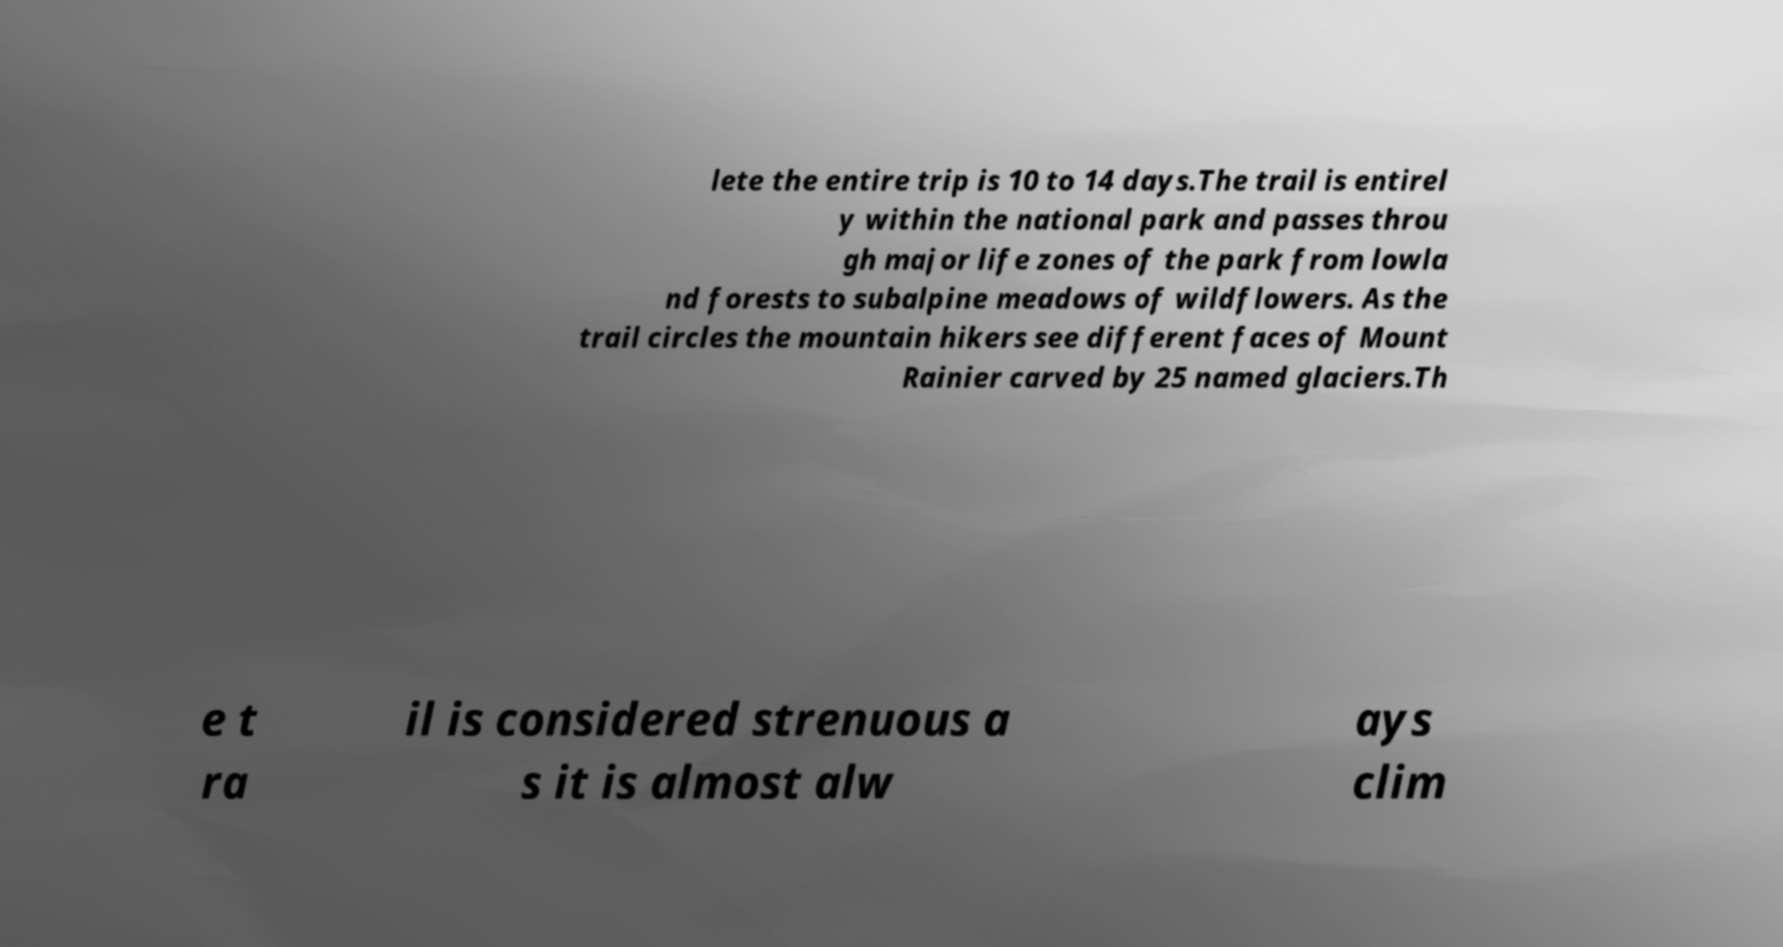For documentation purposes, I need the text within this image transcribed. Could you provide that? lete the entire trip is 10 to 14 days.The trail is entirel y within the national park and passes throu gh major life zones of the park from lowla nd forests to subalpine meadows of wildflowers. As the trail circles the mountain hikers see different faces of Mount Rainier carved by 25 named glaciers.Th e t ra il is considered strenuous a s it is almost alw ays clim 